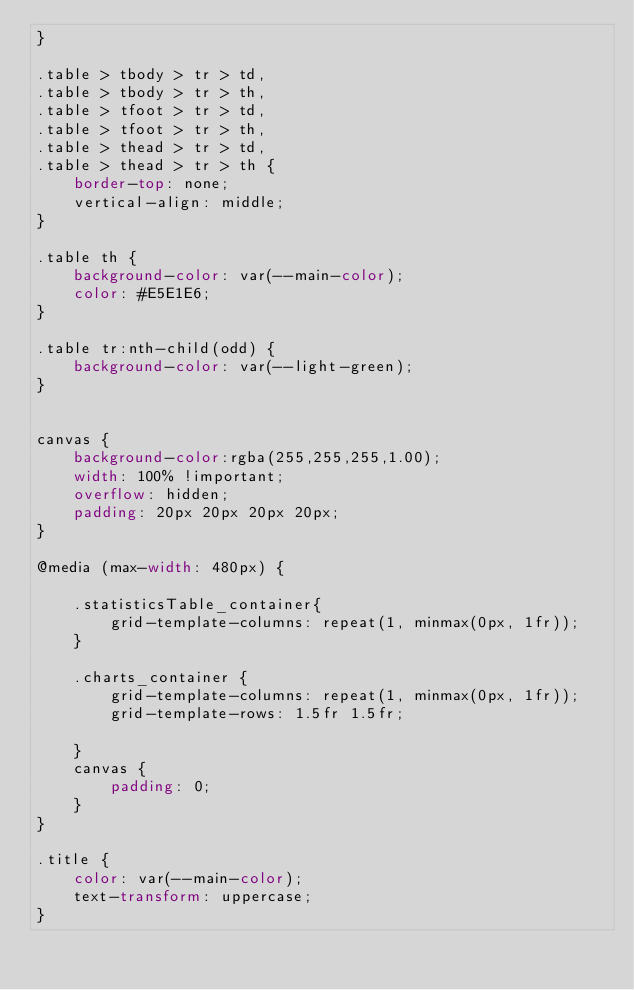<code> <loc_0><loc_0><loc_500><loc_500><_CSS_>}

.table > tbody > tr > td,
.table > tbody > tr > th,
.table > tfoot > tr > td,
.table > tfoot > tr > th,
.table > thead > tr > td,
.table > thead > tr > th {
    border-top: none;
    vertical-align: middle;
}

.table th {
    background-color: var(--main-color);
    color: #E5E1E6;
}

.table tr:nth-child(odd) {
    background-color: var(--light-green);
}


canvas {
    background-color:rgba(255,255,255,1.00);
    width: 100% !important;
    overflow: hidden;
    padding: 20px 20px 20px 20px;
}

@media (max-width: 480px) {

    .statisticsTable_container{
        grid-template-columns: repeat(1, minmax(0px, 1fr));
    }

    .charts_container {
        grid-template-columns: repeat(1, minmax(0px, 1fr));
        grid-template-rows: 1.5fr 1.5fr;

    }
    canvas {
        padding: 0;
    }
}

.title {
    color: var(--main-color);
    text-transform: uppercase;
}
</code> 